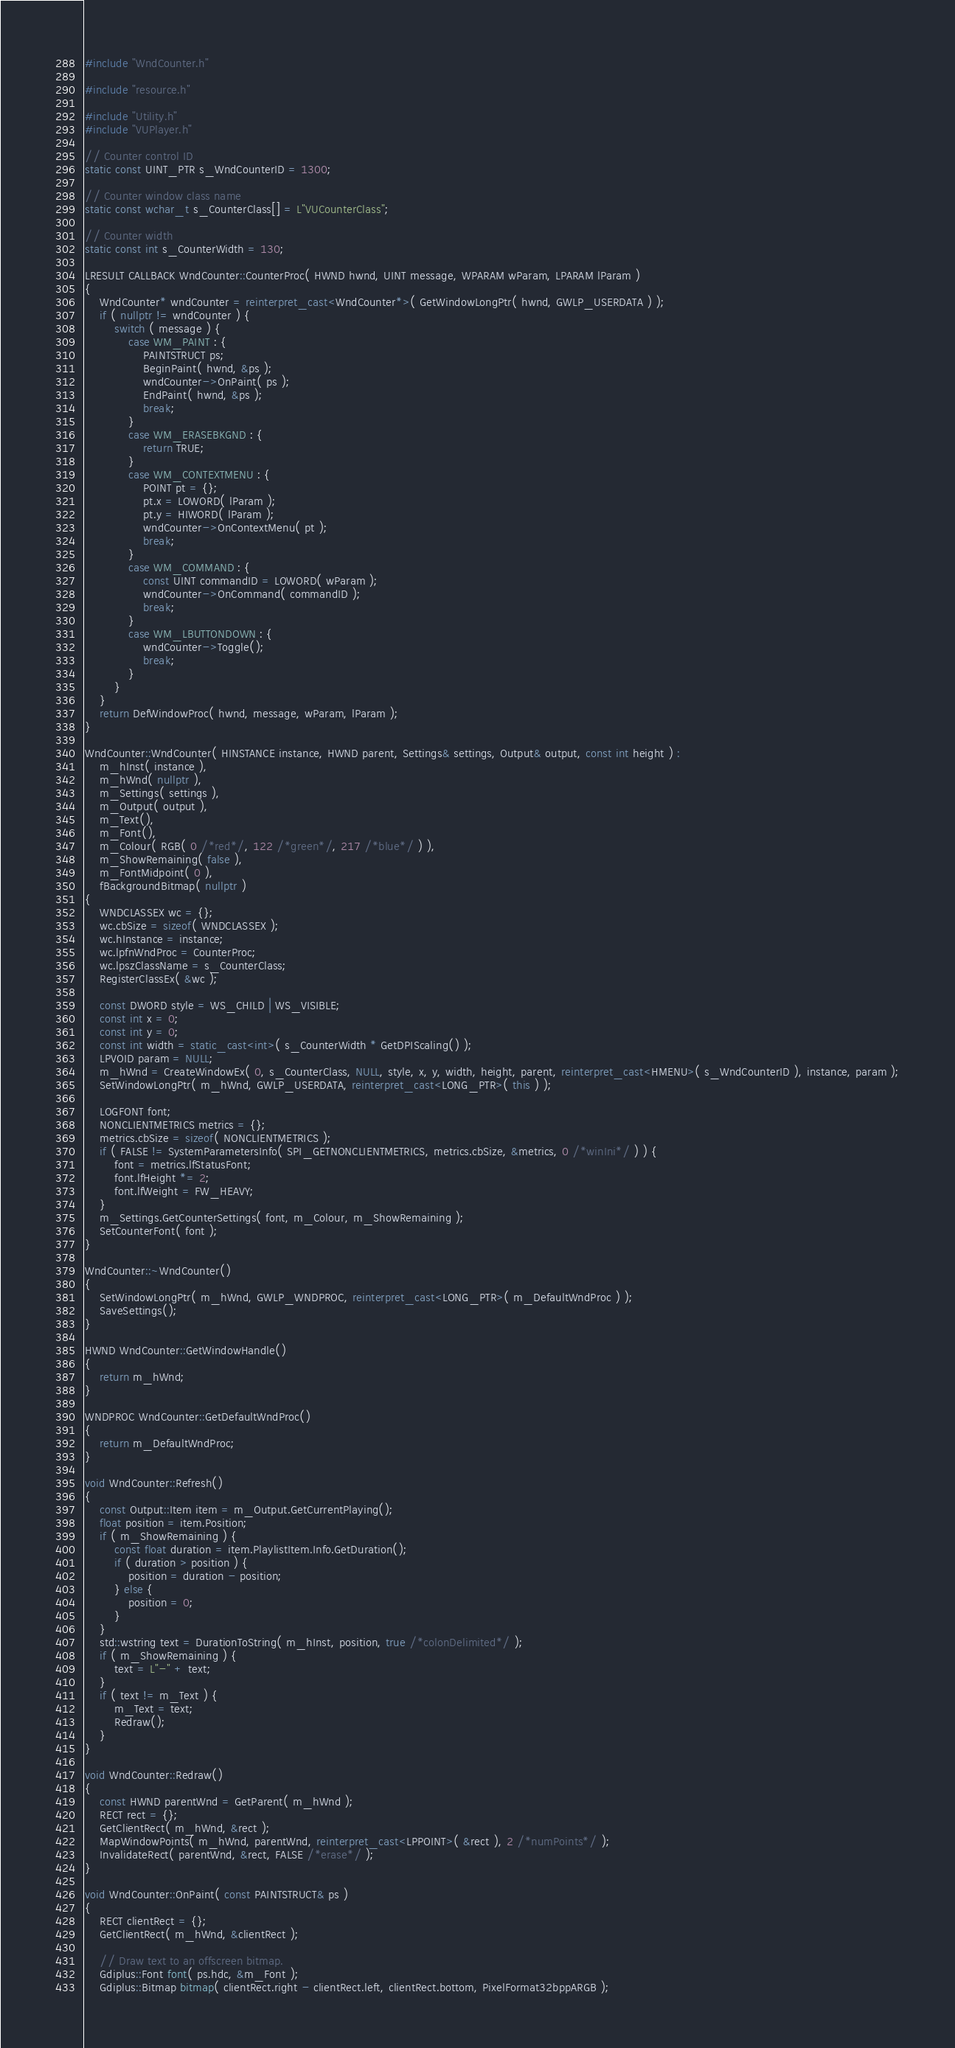<code> <loc_0><loc_0><loc_500><loc_500><_C++_>#include "WndCounter.h"

#include "resource.h"

#include "Utility.h"
#include "VUPlayer.h"

// Counter control ID
static const UINT_PTR s_WndCounterID = 1300;

// Counter window class name
static const wchar_t s_CounterClass[] = L"VUCounterClass";

// Counter width
static const int s_CounterWidth = 130;

LRESULT CALLBACK WndCounter::CounterProc( HWND hwnd, UINT message, WPARAM wParam, LPARAM lParam )
{
	WndCounter* wndCounter = reinterpret_cast<WndCounter*>( GetWindowLongPtr( hwnd, GWLP_USERDATA ) );
	if ( nullptr != wndCounter ) {
		switch ( message ) {
			case WM_PAINT : {
				PAINTSTRUCT ps;
				BeginPaint( hwnd, &ps );
				wndCounter->OnPaint( ps );
				EndPaint( hwnd, &ps );
				break;
			}
			case WM_ERASEBKGND : {
				return TRUE;
			}
			case WM_CONTEXTMENU : {
				POINT pt = {};
				pt.x = LOWORD( lParam );
				pt.y = HIWORD( lParam );
				wndCounter->OnContextMenu( pt );
				break;
			}
			case WM_COMMAND : {
				const UINT commandID = LOWORD( wParam );
				wndCounter->OnCommand( commandID );
				break;
			}
			case WM_LBUTTONDOWN : {
				wndCounter->Toggle();
				break;
			}
		}
	}
	return DefWindowProc( hwnd, message, wParam, lParam );
}

WndCounter::WndCounter( HINSTANCE instance, HWND parent, Settings& settings, Output& output, const int height ) :
	m_hInst( instance ),
	m_hWnd( nullptr ),
	m_Settings( settings ),
	m_Output( output ),
	m_Text(),
	m_Font(),
	m_Colour( RGB( 0 /*red*/, 122 /*green*/, 217 /*blue*/ ) ),
	m_ShowRemaining( false ),
	m_FontMidpoint( 0 ),
	fBackgroundBitmap( nullptr )
{
	WNDCLASSEX wc = {};
	wc.cbSize = sizeof( WNDCLASSEX );
	wc.hInstance = instance;
	wc.lpfnWndProc = CounterProc;
	wc.lpszClassName = s_CounterClass;
	RegisterClassEx( &wc );

	const DWORD style = WS_CHILD | WS_VISIBLE;
	const int x = 0;
	const int y = 0;
	const int width = static_cast<int>( s_CounterWidth * GetDPIScaling() );
	LPVOID param = NULL;
	m_hWnd = CreateWindowEx( 0, s_CounterClass, NULL, style, x, y, width, height, parent, reinterpret_cast<HMENU>( s_WndCounterID ), instance, param );
	SetWindowLongPtr( m_hWnd, GWLP_USERDATA, reinterpret_cast<LONG_PTR>( this ) );

	LOGFONT font;
	NONCLIENTMETRICS metrics = {};
	metrics.cbSize = sizeof( NONCLIENTMETRICS );
	if ( FALSE != SystemParametersInfo( SPI_GETNONCLIENTMETRICS, metrics.cbSize, &metrics, 0 /*winIni*/ ) ) {
		font = metrics.lfStatusFont;
		font.lfHeight *= 2;
		font.lfWeight = FW_HEAVY;
	}
	m_Settings.GetCounterSettings( font, m_Colour, m_ShowRemaining );
	SetCounterFont( font );
}

WndCounter::~WndCounter()
{
	SetWindowLongPtr( m_hWnd, GWLP_WNDPROC, reinterpret_cast<LONG_PTR>( m_DefaultWndProc ) );
	SaveSettings();
}

HWND WndCounter::GetWindowHandle()
{
	return m_hWnd;
}

WNDPROC WndCounter::GetDefaultWndProc()
{
	return m_DefaultWndProc;
}

void WndCounter::Refresh()
{
	const Output::Item item = m_Output.GetCurrentPlaying();
	float position = item.Position;
	if ( m_ShowRemaining ) {
		const float duration = item.PlaylistItem.Info.GetDuration();
		if ( duration > position ) {
			position = duration - position;
		} else {
			position = 0;
		}
	}
	std::wstring text = DurationToString( m_hInst, position, true /*colonDelimited*/ );
	if ( m_ShowRemaining ) {
		text = L"-" + text;
	}
	if ( text != m_Text ) {
		m_Text = text;
		Redraw();
	}
}

void WndCounter::Redraw()
{
	const HWND parentWnd = GetParent( m_hWnd );
	RECT rect = {};
	GetClientRect( m_hWnd, &rect );
	MapWindowPoints( m_hWnd, parentWnd, reinterpret_cast<LPPOINT>( &rect ), 2 /*numPoints*/ );
	InvalidateRect( parentWnd, &rect, FALSE /*erase*/ );
}

void WndCounter::OnPaint( const PAINTSTRUCT& ps )
{
	RECT clientRect = {};
	GetClientRect( m_hWnd, &clientRect );

	// Draw text to an offscreen bitmap.
	Gdiplus::Font font( ps.hdc, &m_Font );
	Gdiplus::Bitmap bitmap( clientRect.right - clientRect.left, clientRect.bottom, PixelFormat32bppARGB );</code> 